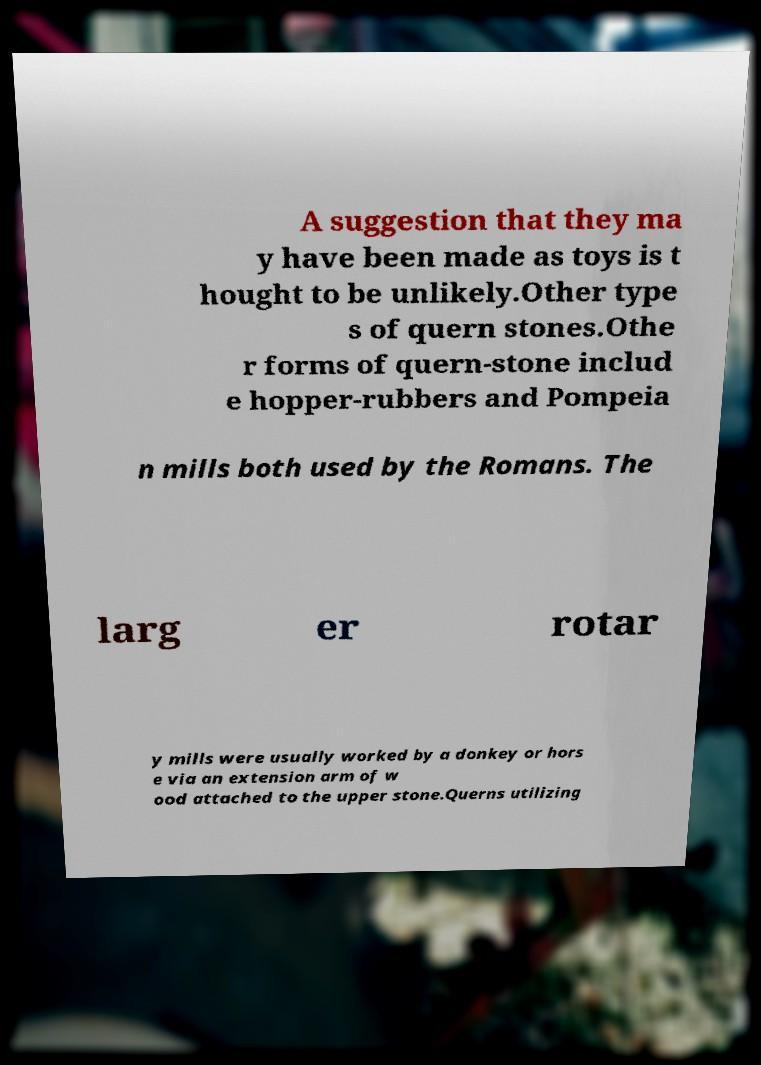Could you extract and type out the text from this image? A suggestion that they ma y have been made as toys is t hought to be unlikely.Other type s of quern stones.Othe r forms of quern-stone includ e hopper-rubbers and Pompeia n mills both used by the Romans. The larg er rotar y mills were usually worked by a donkey or hors e via an extension arm of w ood attached to the upper stone.Querns utilizing 